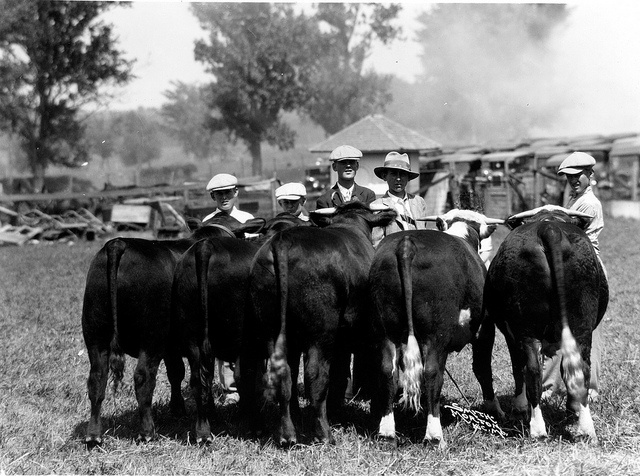Describe the objects in this image and their specific colors. I can see cow in gray, black, darkgray, and lightgray tones, cow in gray, black, lightgray, and darkgray tones, cow in gray, black, white, and darkgray tones, cow in gray, black, darkgray, and gainsboro tones, and cow in gray, black, darkgray, and lightgray tones in this image. 